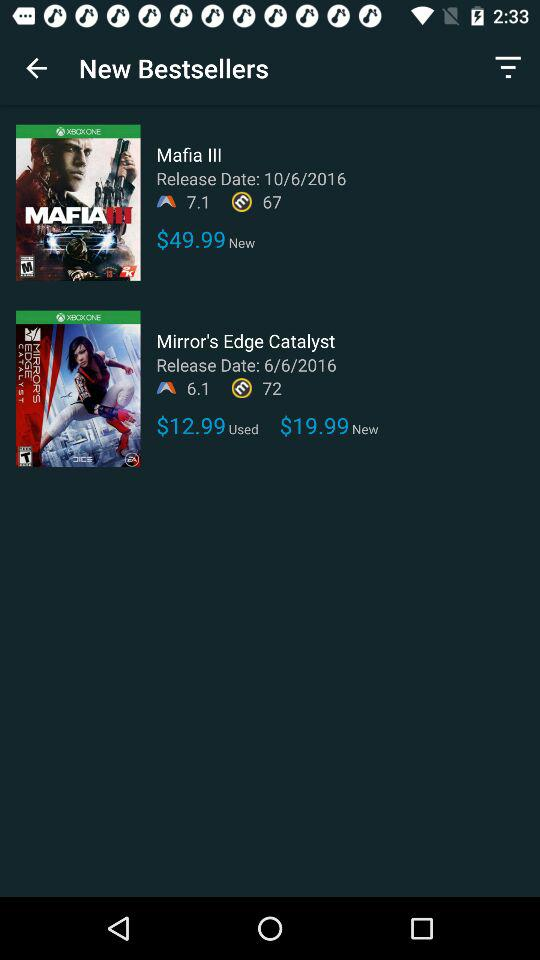What is the price of the used "Mirror's Edge Catalyst" game? The price of the used "Mirror's Edge Catalyst" game is $12.99. 